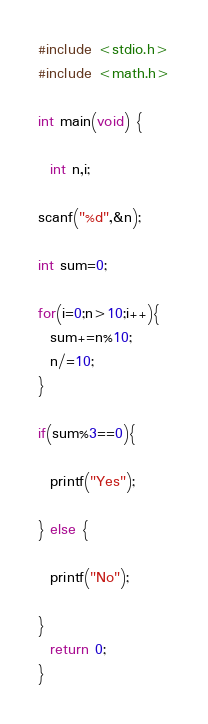<code> <loc_0><loc_0><loc_500><loc_500><_C_>#include <stdio.h>
#include <math.h>

int main(void) {
 
  int n,i;

scanf("%d",&n);

int sum=0;

for(i=0;n>10;i++){
  sum+=n%10;
  n/=10;
}

if(sum%3==0){

  printf("Yes");

} else {

  printf("No");

}
  return 0;
}</code> 